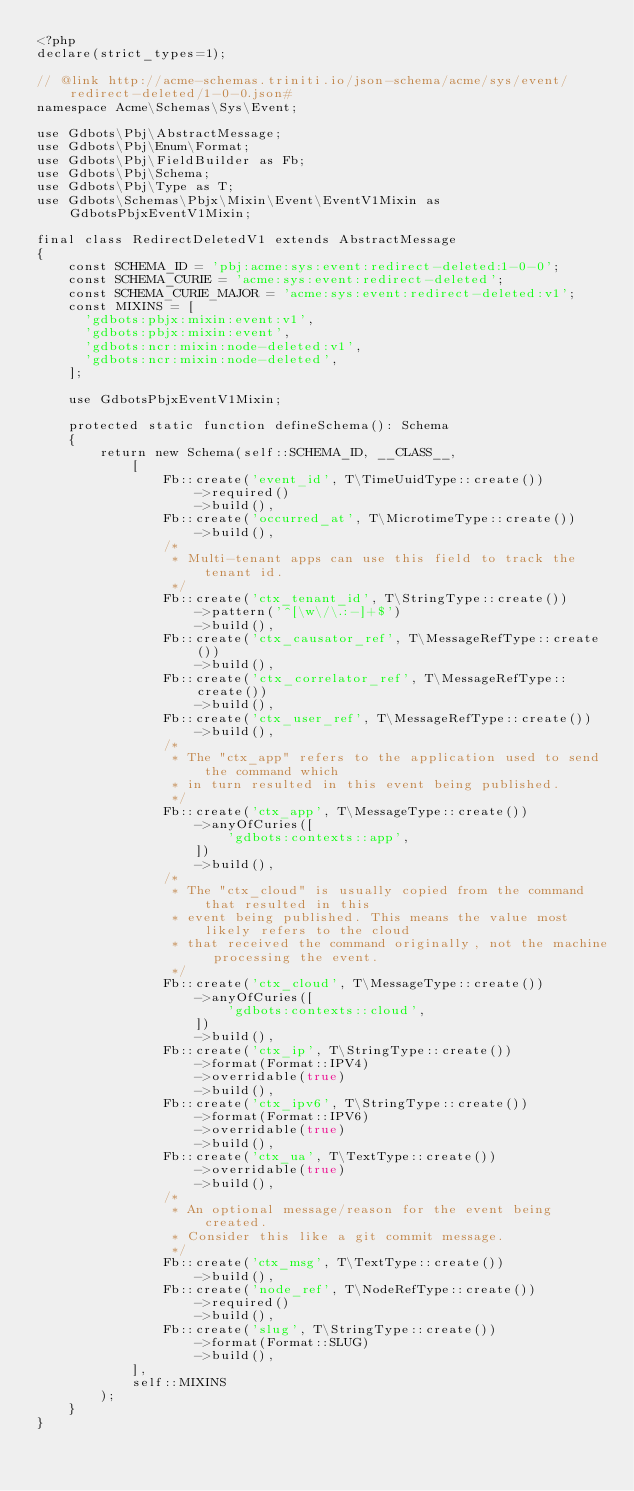Convert code to text. <code><loc_0><loc_0><loc_500><loc_500><_PHP_><?php
declare(strict_types=1);

// @link http://acme-schemas.triniti.io/json-schema/acme/sys/event/redirect-deleted/1-0-0.json#
namespace Acme\Schemas\Sys\Event;

use Gdbots\Pbj\AbstractMessage;
use Gdbots\Pbj\Enum\Format;
use Gdbots\Pbj\FieldBuilder as Fb;
use Gdbots\Pbj\Schema;
use Gdbots\Pbj\Type as T;
use Gdbots\Schemas\Pbjx\Mixin\Event\EventV1Mixin as GdbotsPbjxEventV1Mixin;

final class RedirectDeletedV1 extends AbstractMessage
{
    const SCHEMA_ID = 'pbj:acme:sys:event:redirect-deleted:1-0-0';
    const SCHEMA_CURIE = 'acme:sys:event:redirect-deleted';
    const SCHEMA_CURIE_MAJOR = 'acme:sys:event:redirect-deleted:v1';
    const MIXINS = [
      'gdbots:pbjx:mixin:event:v1',
      'gdbots:pbjx:mixin:event',
      'gdbots:ncr:mixin:node-deleted:v1',
      'gdbots:ncr:mixin:node-deleted',
    ];

    use GdbotsPbjxEventV1Mixin;

    protected static function defineSchema(): Schema
    {
        return new Schema(self::SCHEMA_ID, __CLASS__,
            [
                Fb::create('event_id', T\TimeUuidType::create())
                    ->required()
                    ->build(),
                Fb::create('occurred_at', T\MicrotimeType::create())
                    ->build(),
                /*
                 * Multi-tenant apps can use this field to track the tenant id.
                 */
                Fb::create('ctx_tenant_id', T\StringType::create())
                    ->pattern('^[\w\/\.:-]+$')
                    ->build(),
                Fb::create('ctx_causator_ref', T\MessageRefType::create())
                    ->build(),
                Fb::create('ctx_correlator_ref', T\MessageRefType::create())
                    ->build(),
                Fb::create('ctx_user_ref', T\MessageRefType::create())
                    ->build(),
                /*
                 * The "ctx_app" refers to the application used to send the command which
                 * in turn resulted in this event being published.
                 */
                Fb::create('ctx_app', T\MessageType::create())
                    ->anyOfCuries([
                        'gdbots:contexts::app',
                    ])
                    ->build(),
                /*
                 * The "ctx_cloud" is usually copied from the command that resulted in this
                 * event being published. This means the value most likely refers to the cloud
                 * that received the command originally, not the machine processing the event.
                 */
                Fb::create('ctx_cloud', T\MessageType::create())
                    ->anyOfCuries([
                        'gdbots:contexts::cloud',
                    ])
                    ->build(),
                Fb::create('ctx_ip', T\StringType::create())
                    ->format(Format::IPV4)
                    ->overridable(true)
                    ->build(),
                Fb::create('ctx_ipv6', T\StringType::create())
                    ->format(Format::IPV6)
                    ->overridable(true)
                    ->build(),
                Fb::create('ctx_ua', T\TextType::create())
                    ->overridable(true)
                    ->build(),
                /*
                 * An optional message/reason for the event being created.
                 * Consider this like a git commit message.
                 */
                Fb::create('ctx_msg', T\TextType::create())
                    ->build(),
                Fb::create('node_ref', T\NodeRefType::create())
                    ->required()
                    ->build(),
                Fb::create('slug', T\StringType::create())
                    ->format(Format::SLUG)
                    ->build(),
            ],
            self::MIXINS
        );
    }
}
</code> 